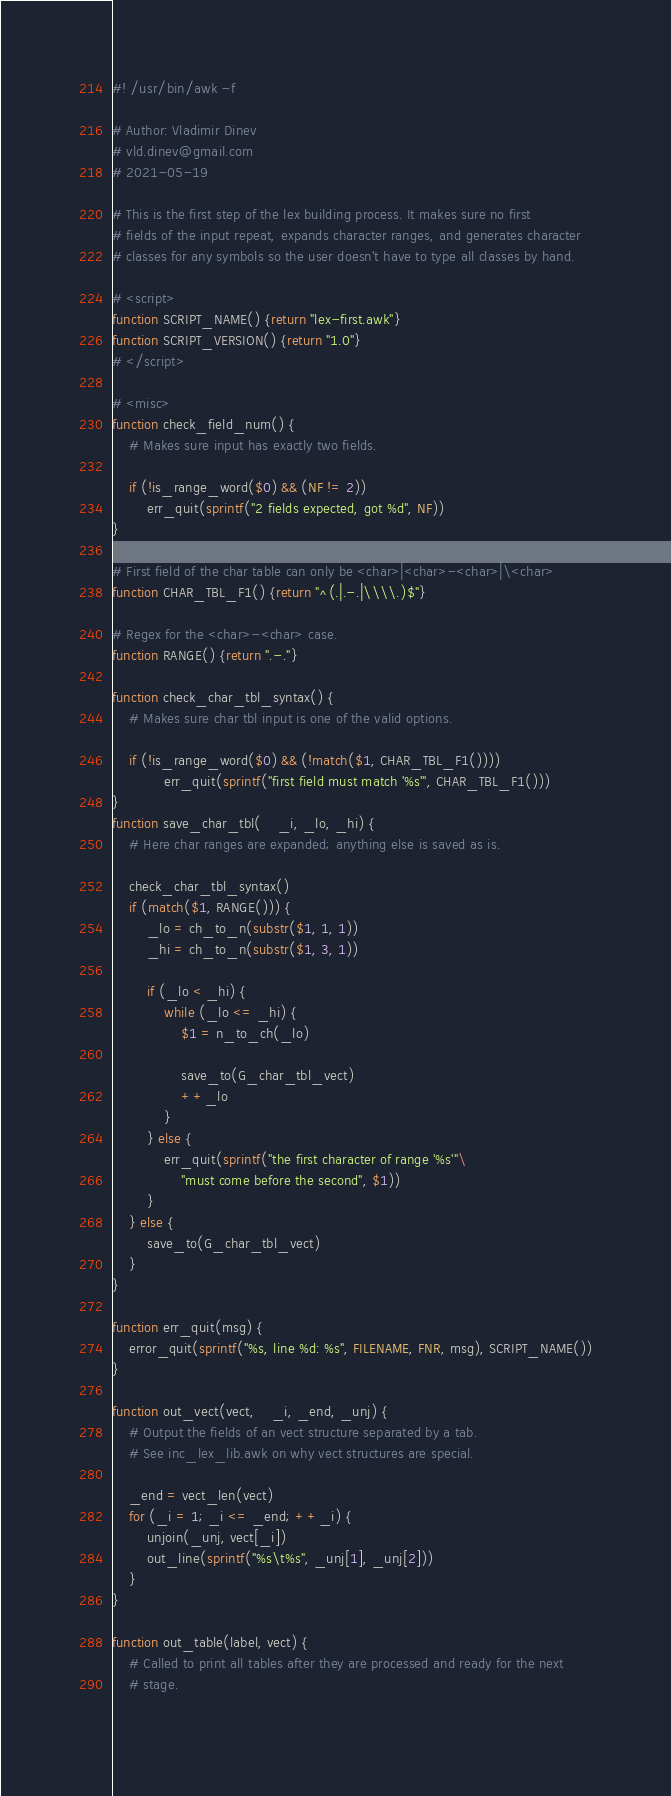Convert code to text. <code><loc_0><loc_0><loc_500><loc_500><_Awk_>#! /usr/bin/awk -f

# Author: Vladimir Dinev
# vld.dinev@gmail.com
# 2021-05-19

# This is the first step of the lex building process. It makes sure no first
# fields of the input repeat, expands character ranges, and generates character
# classes for any symbols so the user doesn't have to type all classes by hand.

# <script>
function SCRIPT_NAME() {return "lex-first.awk"}
function SCRIPT_VERSION() {return "1.0"}
# </script>

# <misc>
function check_field_num() {
	# Makes sure input has exactly two fields.
	
	if (!is_range_word($0) && (NF != 2))
		err_quit(sprintf("2 fields expected, got %d", NF))
}

# First field of the char table can only be <char>|<char>-<char>|\<char>
function CHAR_TBL_F1() {return "^(.|.-.|\\\\.)$"}

# Regex for the <char>-<char> case.
function RANGE() {return ".-."}

function check_char_tbl_syntax() {
	# Makes sure char tbl input is one of the valid options.

	if (!is_range_word($0) && (!match($1, CHAR_TBL_F1())))
			err_quit(sprintf("first field must match '%s'", CHAR_TBL_F1()))
}
function save_char_tbl(    _i, _lo, _hi) {
	# Here char ranges are expanded; anything else is saved as is.
	
	check_char_tbl_syntax()
	if (match($1, RANGE())) {
		_lo = ch_to_n(substr($1, 1, 1))
		_hi = ch_to_n(substr($1, 3, 1))
		
		if (_lo < _hi) {
			while (_lo <= _hi) {
				$1 = n_to_ch(_lo)

				save_to(G_char_tbl_vect)
				++_lo
			}
		} else {
			err_quit(sprintf("the first character of range '%s'"\
				"must come before the second", $1))
		}
	} else {
		save_to(G_char_tbl_vect)
	}
}

function err_quit(msg) {
	error_quit(sprintf("%s, line %d: %s", FILENAME, FNR, msg), SCRIPT_NAME())
}

function out_vect(vect,    _i, _end, _unj) {
	# Output the fields of an vect structure separated by a tab.
	# See inc_lex_lib.awk on why vect structures are special.
	
	_end = vect_len(vect)
	for (_i = 1; _i <= _end; ++_i) {
		unjoin(_unj, vect[_i])
		out_line(sprintf("%s\t%s", _unj[1], _unj[2]))
	}
}

function out_table(label, vect) {
	# Called to print all tables after they are processed and ready for the next
	# stage.
	</code> 